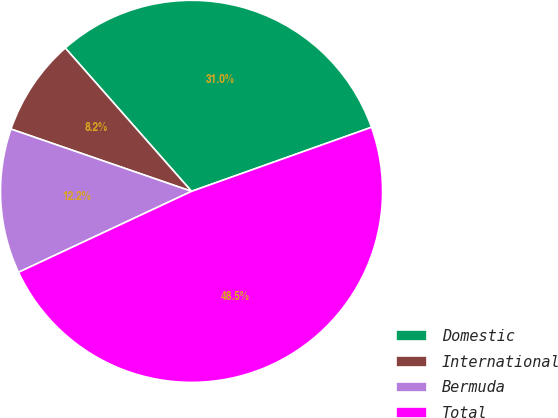<chart> <loc_0><loc_0><loc_500><loc_500><pie_chart><fcel>Domestic<fcel>International<fcel>Bermuda<fcel>Total<nl><fcel>31.05%<fcel>8.22%<fcel>12.25%<fcel>48.48%<nl></chart> 